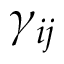Convert formula to latex. <formula><loc_0><loc_0><loc_500><loc_500>\gamma _ { i j }</formula> 